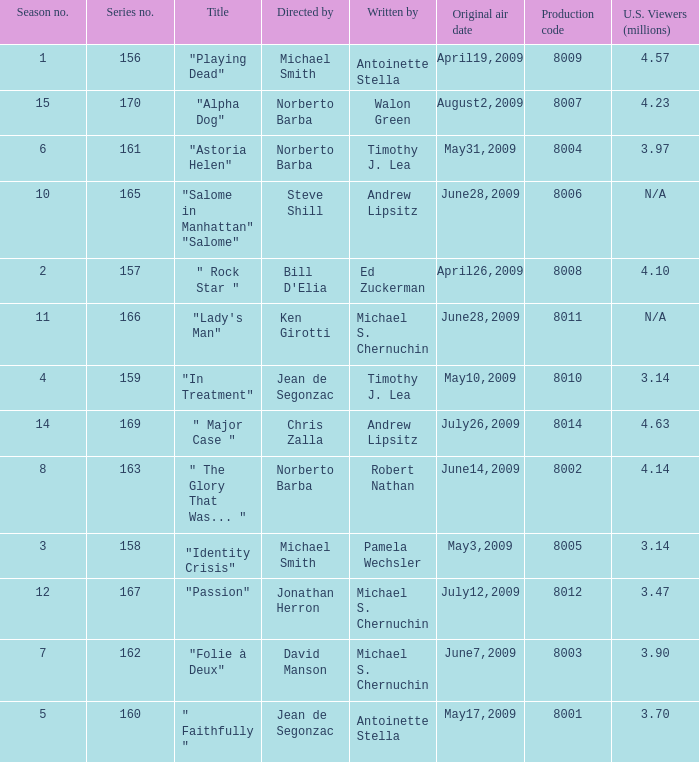Who are the authors when the production code is 8011? Michael S. Chernuchin. 